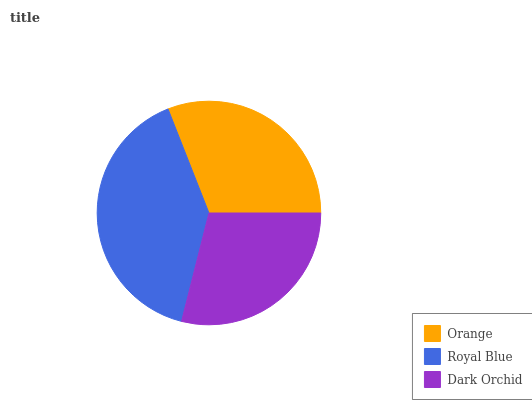Is Dark Orchid the minimum?
Answer yes or no. Yes. Is Royal Blue the maximum?
Answer yes or no. Yes. Is Royal Blue the minimum?
Answer yes or no. No. Is Dark Orchid the maximum?
Answer yes or no. No. Is Royal Blue greater than Dark Orchid?
Answer yes or no. Yes. Is Dark Orchid less than Royal Blue?
Answer yes or no. Yes. Is Dark Orchid greater than Royal Blue?
Answer yes or no. No. Is Royal Blue less than Dark Orchid?
Answer yes or no. No. Is Orange the high median?
Answer yes or no. Yes. Is Orange the low median?
Answer yes or no. Yes. Is Royal Blue the high median?
Answer yes or no. No. Is Royal Blue the low median?
Answer yes or no. No. 